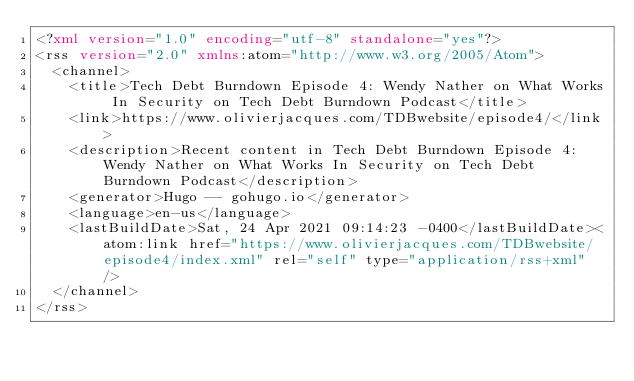<code> <loc_0><loc_0><loc_500><loc_500><_XML_><?xml version="1.0" encoding="utf-8" standalone="yes"?>
<rss version="2.0" xmlns:atom="http://www.w3.org/2005/Atom">
  <channel>
    <title>Tech Debt Burndown Episode 4: Wendy Nather on What Works In Security on Tech Debt Burndown Podcast</title>
    <link>https://www.olivierjacques.com/TDBwebsite/episode4/</link>
    <description>Recent content in Tech Debt Burndown Episode 4: Wendy Nather on What Works In Security on Tech Debt Burndown Podcast</description>
    <generator>Hugo -- gohugo.io</generator>
    <language>en-us</language>
    <lastBuildDate>Sat, 24 Apr 2021 09:14:23 -0400</lastBuildDate><atom:link href="https://www.olivierjacques.com/TDBwebsite/episode4/index.xml" rel="self" type="application/rss+xml" />
  </channel>
</rss>
</code> 